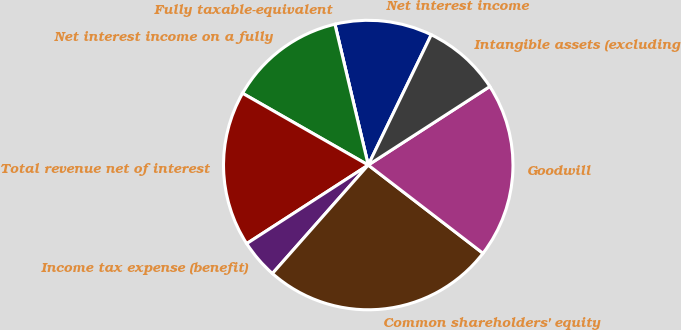Convert chart. <chart><loc_0><loc_0><loc_500><loc_500><pie_chart><fcel>Net interest income<fcel>Fully taxable-equivalent<fcel>Net interest income on a fully<fcel>Total revenue net of interest<fcel>Income tax expense (benefit)<fcel>Common shareholders' equity<fcel>Goodwill<fcel>Intangible assets (excluding<nl><fcel>10.87%<fcel>0.0%<fcel>13.04%<fcel>17.39%<fcel>4.35%<fcel>26.08%<fcel>19.56%<fcel>8.7%<nl></chart> 